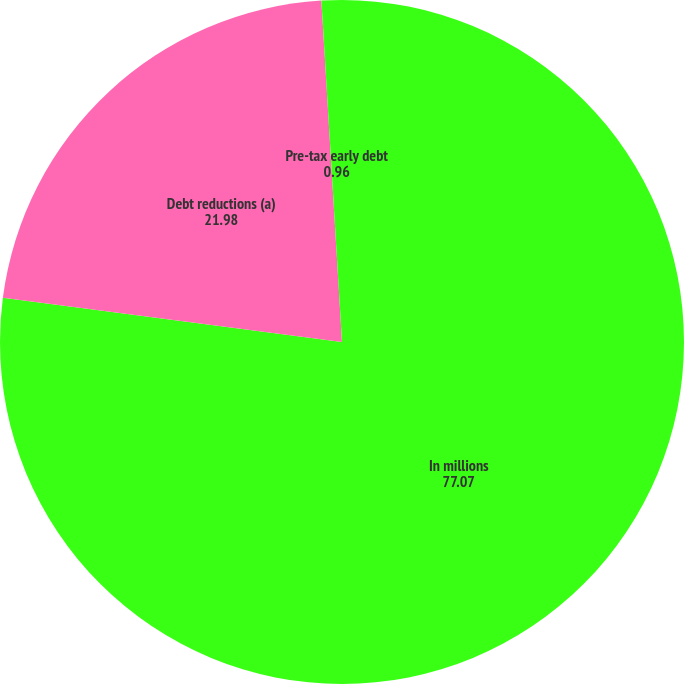Convert chart. <chart><loc_0><loc_0><loc_500><loc_500><pie_chart><fcel>In millions<fcel>Debt reductions (a)<fcel>Pre-tax early debt<nl><fcel>77.07%<fcel>21.98%<fcel>0.96%<nl></chart> 